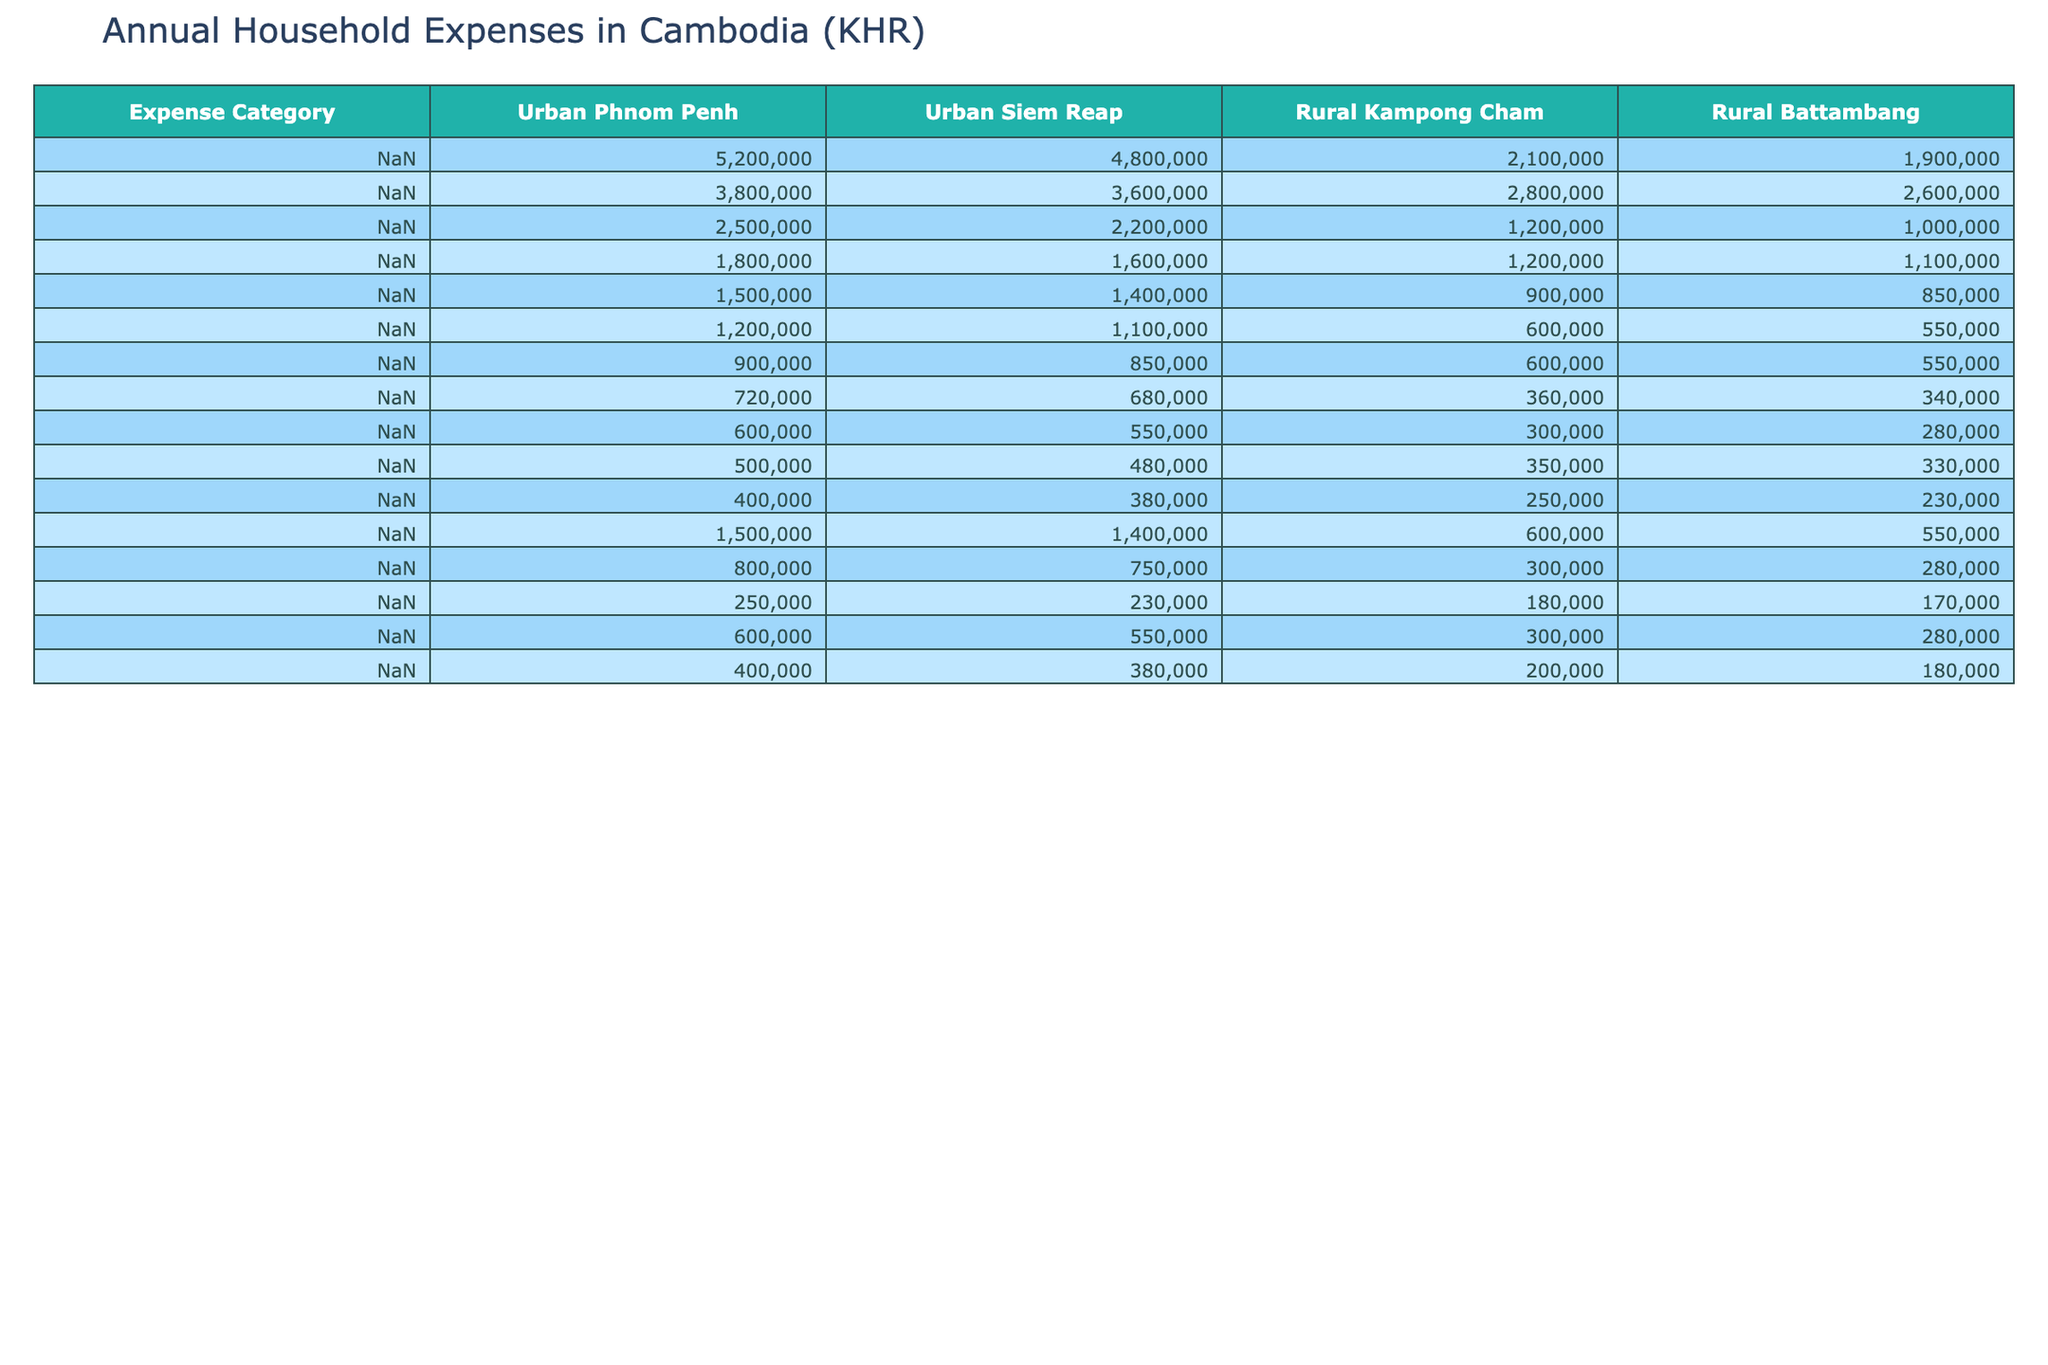What is the total annual housing expense for a family in urban Phnom Penh? The table shows that the housing expense in urban Phnom Penh is 5,200,000 KHR.
Answer: 5,200,000 KHR What is the average food and grocery expense for rural families in Kampong Cham and Battambang? The food expense for Kampong Cham is 2,800,000 KHR and for Battambang is 2,600,000 KHR. The average is (2,800,000 + 2,600,000) / 2 = 2,700,000 KHR.
Answer: 2,700,000 KHR Is the healthcare expense higher in urban Siem Reap compared to urban Phnom Penh? The healthcare expense in urban Siem Reap is 1,600,000 KHR, while in urban Phnom Penh it is 1,800,000 KHR. Therefore, it is false that it is higher in Siem Reap.
Answer: No Which urban area has the highest education expense? The education expense for urban Phnom Penh is 2,500,000 KHR and for urban Siem Reap is 2,200,000 KHR. Since 2,500,000 KHR is greater, urban Phnom Penh has the highest education expense.
Answer: Urban Phnom Penh What is the difference in transportation expenses between rural Kampong Cham and urban Siem Reap? The transportation expense in rural Kampong Cham is 900,000 KHR and in urban Siem Reap is 1,400,000 KHR. The difference is 1,400,000 - 900,000 = 500,000 KHR.
Answer: 500,000 KHR What is the combined total of personal care and entertainment expenses for families in rural Battambang? The personal care expense in rural Battambang is 230,000 KHR and the entertainment expense is 280,000 KHR. The combined total is 230,000 + 280,000 = 510,000 KHR.
Answer: 510,000 KHR Which expense category has the lowest total when comparing urban and rural areas? By comparing categories across both urban areas and rural areas, clothing has the lowest values: 900,000 KHR (urban Phnom Penh) and 550,000 KHR (rural Battambang), giving a total of 1,450,000 KHR.
Answer: Clothing What is the average amount spent on savings/investments by families in urban areas? The savings/investments in urban Phnom Penh is 1,500,000 KHR and in urban Siem Reap is 1,400,000 KHR. The average is (1,500,000 + 1,400,000) / 2 = 1,450,000 KHR.
Answer: 1,450,000 KHR How much more do urban families in Phnom Penh spend on utilities than rural families in Kampong Cham? Urban Phnom Penh spends 1,200,000 KHR on utilities, while rural Kampong Cham spends 600,000 KHR. The difference is 1,200,000 - 600,000 = 600,000 KHR.
Answer: 600,000 KHR Do families in urban Siem Reap spend more on clothing than those in rural Battambang? Clothing expenses are 850,000 KHR in urban Siem Reap and 550,000 KHR in rural Battambang. Since 850,000 is more than 550,000, the statement is true.
Answer: Yes 